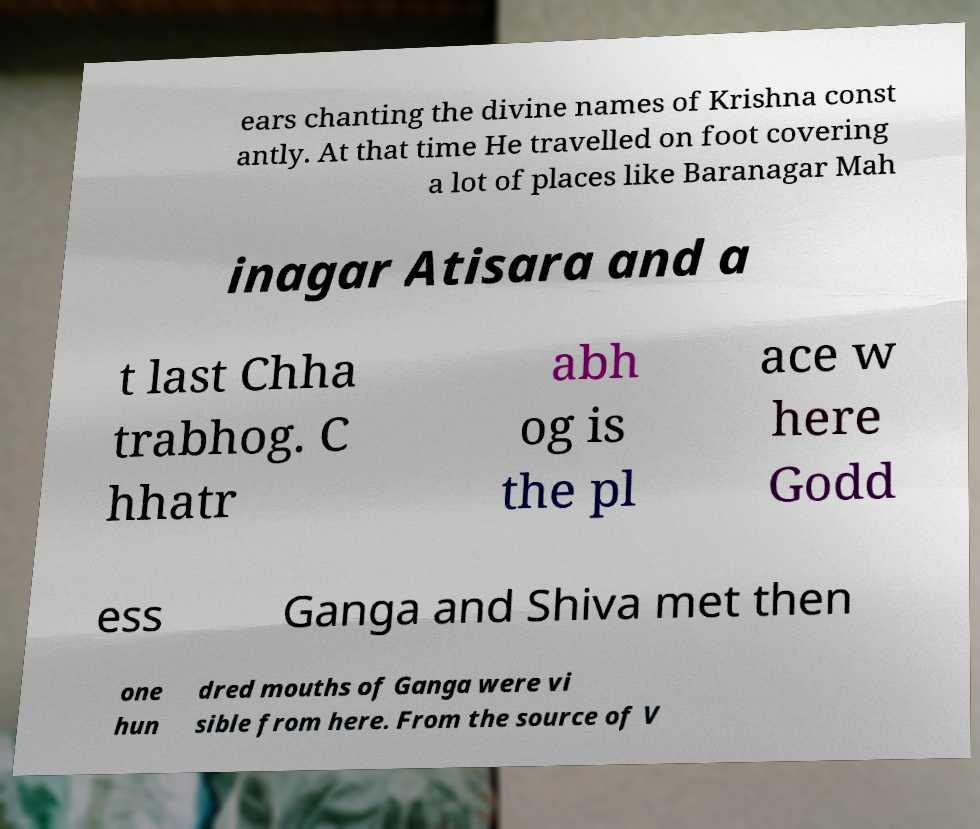There's text embedded in this image that I need extracted. Can you transcribe it verbatim? ears chanting the divine names of Krishna const antly. At that time He travelled on foot covering a lot of places like Baranagar Mah inagar Atisara and a t last Chha trabhog. C hhatr abh og is the pl ace w here Godd ess Ganga and Shiva met then one hun dred mouths of Ganga were vi sible from here. From the source of V 